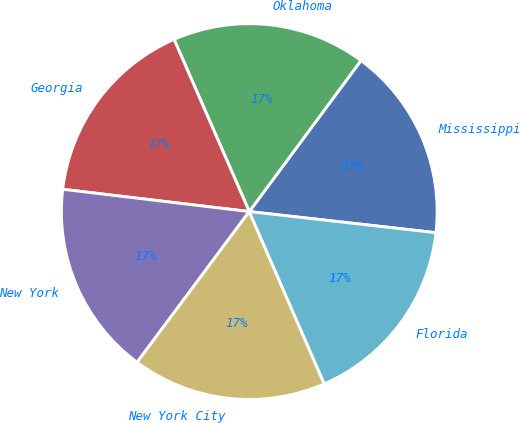Convert chart to OTSL. <chart><loc_0><loc_0><loc_500><loc_500><pie_chart><fcel>Mississippi<fcel>Oklahoma<fcel>Georgia<fcel>New York<fcel>New York City<fcel>Florida<nl><fcel>16.66%<fcel>16.69%<fcel>16.55%<fcel>16.71%<fcel>16.72%<fcel>16.67%<nl></chart> 